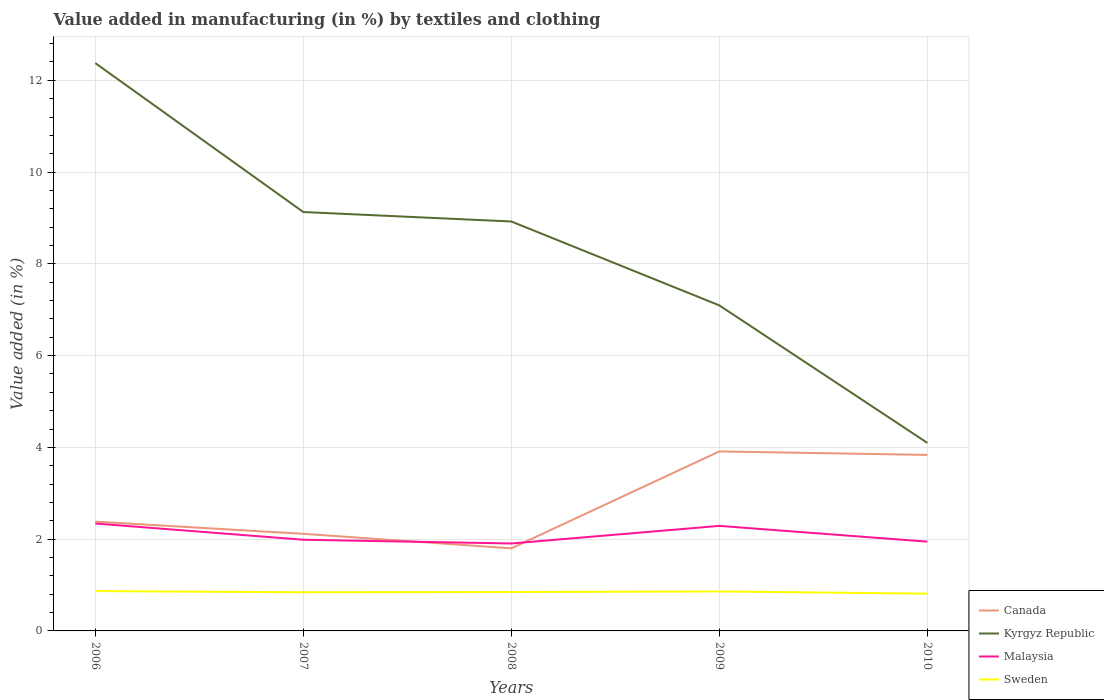How many different coloured lines are there?
Keep it short and to the point. 4. Does the line corresponding to Canada intersect with the line corresponding to Kyrgyz Republic?
Your response must be concise. No. Across all years, what is the maximum percentage of value added in manufacturing by textiles and clothing in Sweden?
Keep it short and to the point. 0.81. What is the total percentage of value added in manufacturing by textiles and clothing in Kyrgyz Republic in the graph?
Provide a succinct answer. 3.25. What is the difference between the highest and the second highest percentage of value added in manufacturing by textiles and clothing in Kyrgyz Republic?
Your response must be concise. 8.28. How many years are there in the graph?
Ensure brevity in your answer.  5. What is the difference between two consecutive major ticks on the Y-axis?
Make the answer very short. 2. Are the values on the major ticks of Y-axis written in scientific E-notation?
Your response must be concise. No. Does the graph contain grids?
Ensure brevity in your answer.  Yes. Where does the legend appear in the graph?
Make the answer very short. Bottom right. How are the legend labels stacked?
Give a very brief answer. Vertical. What is the title of the graph?
Keep it short and to the point. Value added in manufacturing (in %) by textiles and clothing. Does "Morocco" appear as one of the legend labels in the graph?
Your response must be concise. No. What is the label or title of the X-axis?
Your answer should be compact. Years. What is the label or title of the Y-axis?
Provide a succinct answer. Value added (in %). What is the Value added (in %) in Canada in 2006?
Offer a terse response. 2.38. What is the Value added (in %) in Kyrgyz Republic in 2006?
Your answer should be very brief. 12.37. What is the Value added (in %) of Malaysia in 2006?
Ensure brevity in your answer.  2.34. What is the Value added (in %) in Sweden in 2006?
Your response must be concise. 0.87. What is the Value added (in %) of Canada in 2007?
Give a very brief answer. 2.12. What is the Value added (in %) in Kyrgyz Republic in 2007?
Ensure brevity in your answer.  9.13. What is the Value added (in %) of Malaysia in 2007?
Provide a succinct answer. 1.99. What is the Value added (in %) in Sweden in 2007?
Give a very brief answer. 0.84. What is the Value added (in %) of Canada in 2008?
Keep it short and to the point. 1.8. What is the Value added (in %) of Kyrgyz Republic in 2008?
Provide a succinct answer. 8.92. What is the Value added (in %) of Malaysia in 2008?
Ensure brevity in your answer.  1.91. What is the Value added (in %) in Sweden in 2008?
Ensure brevity in your answer.  0.85. What is the Value added (in %) in Canada in 2009?
Keep it short and to the point. 3.91. What is the Value added (in %) in Kyrgyz Republic in 2009?
Your answer should be compact. 7.09. What is the Value added (in %) of Malaysia in 2009?
Provide a succinct answer. 2.29. What is the Value added (in %) of Sweden in 2009?
Your answer should be very brief. 0.86. What is the Value added (in %) in Canada in 2010?
Ensure brevity in your answer.  3.84. What is the Value added (in %) of Kyrgyz Republic in 2010?
Provide a succinct answer. 4.1. What is the Value added (in %) of Malaysia in 2010?
Keep it short and to the point. 1.95. What is the Value added (in %) of Sweden in 2010?
Your answer should be compact. 0.81. Across all years, what is the maximum Value added (in %) of Canada?
Your answer should be very brief. 3.91. Across all years, what is the maximum Value added (in %) of Kyrgyz Republic?
Give a very brief answer. 12.37. Across all years, what is the maximum Value added (in %) in Malaysia?
Provide a short and direct response. 2.34. Across all years, what is the maximum Value added (in %) of Sweden?
Ensure brevity in your answer.  0.87. Across all years, what is the minimum Value added (in %) in Canada?
Offer a very short reply. 1.8. Across all years, what is the minimum Value added (in %) in Kyrgyz Republic?
Your answer should be compact. 4.1. Across all years, what is the minimum Value added (in %) in Malaysia?
Ensure brevity in your answer.  1.91. Across all years, what is the minimum Value added (in %) of Sweden?
Ensure brevity in your answer.  0.81. What is the total Value added (in %) in Canada in the graph?
Offer a very short reply. 14.05. What is the total Value added (in %) in Kyrgyz Republic in the graph?
Offer a terse response. 41.62. What is the total Value added (in %) of Malaysia in the graph?
Make the answer very short. 10.47. What is the total Value added (in %) of Sweden in the graph?
Offer a very short reply. 4.23. What is the difference between the Value added (in %) of Canada in 2006 and that in 2007?
Make the answer very short. 0.27. What is the difference between the Value added (in %) of Kyrgyz Republic in 2006 and that in 2007?
Your answer should be compact. 3.25. What is the difference between the Value added (in %) in Malaysia in 2006 and that in 2007?
Keep it short and to the point. 0.35. What is the difference between the Value added (in %) of Sweden in 2006 and that in 2007?
Ensure brevity in your answer.  0.03. What is the difference between the Value added (in %) in Canada in 2006 and that in 2008?
Your answer should be very brief. 0.58. What is the difference between the Value added (in %) in Kyrgyz Republic in 2006 and that in 2008?
Give a very brief answer. 3.45. What is the difference between the Value added (in %) in Malaysia in 2006 and that in 2008?
Your response must be concise. 0.44. What is the difference between the Value added (in %) of Sweden in 2006 and that in 2008?
Your answer should be compact. 0.02. What is the difference between the Value added (in %) of Canada in 2006 and that in 2009?
Your answer should be compact. -1.53. What is the difference between the Value added (in %) of Kyrgyz Republic in 2006 and that in 2009?
Offer a terse response. 5.28. What is the difference between the Value added (in %) of Malaysia in 2006 and that in 2009?
Your answer should be compact. 0.05. What is the difference between the Value added (in %) in Sweden in 2006 and that in 2009?
Offer a very short reply. 0.01. What is the difference between the Value added (in %) in Canada in 2006 and that in 2010?
Provide a succinct answer. -1.45. What is the difference between the Value added (in %) of Kyrgyz Republic in 2006 and that in 2010?
Provide a succinct answer. 8.28. What is the difference between the Value added (in %) of Malaysia in 2006 and that in 2010?
Provide a short and direct response. 0.4. What is the difference between the Value added (in %) in Sweden in 2006 and that in 2010?
Offer a terse response. 0.06. What is the difference between the Value added (in %) of Canada in 2007 and that in 2008?
Provide a short and direct response. 0.32. What is the difference between the Value added (in %) in Kyrgyz Republic in 2007 and that in 2008?
Offer a very short reply. 0.21. What is the difference between the Value added (in %) of Malaysia in 2007 and that in 2008?
Offer a very short reply. 0.08. What is the difference between the Value added (in %) in Sweden in 2007 and that in 2008?
Ensure brevity in your answer.  -0.01. What is the difference between the Value added (in %) in Canada in 2007 and that in 2009?
Your answer should be very brief. -1.8. What is the difference between the Value added (in %) in Kyrgyz Republic in 2007 and that in 2009?
Keep it short and to the point. 2.03. What is the difference between the Value added (in %) in Malaysia in 2007 and that in 2009?
Offer a terse response. -0.3. What is the difference between the Value added (in %) in Sweden in 2007 and that in 2009?
Give a very brief answer. -0.02. What is the difference between the Value added (in %) of Canada in 2007 and that in 2010?
Offer a terse response. -1.72. What is the difference between the Value added (in %) in Kyrgyz Republic in 2007 and that in 2010?
Your response must be concise. 5.03. What is the difference between the Value added (in %) of Malaysia in 2007 and that in 2010?
Your response must be concise. 0.04. What is the difference between the Value added (in %) in Sweden in 2007 and that in 2010?
Your answer should be compact. 0.03. What is the difference between the Value added (in %) in Canada in 2008 and that in 2009?
Keep it short and to the point. -2.11. What is the difference between the Value added (in %) in Kyrgyz Republic in 2008 and that in 2009?
Offer a terse response. 1.83. What is the difference between the Value added (in %) of Malaysia in 2008 and that in 2009?
Provide a succinct answer. -0.38. What is the difference between the Value added (in %) in Sweden in 2008 and that in 2009?
Your answer should be very brief. -0.01. What is the difference between the Value added (in %) in Canada in 2008 and that in 2010?
Your answer should be compact. -2.04. What is the difference between the Value added (in %) of Kyrgyz Republic in 2008 and that in 2010?
Give a very brief answer. 4.82. What is the difference between the Value added (in %) of Malaysia in 2008 and that in 2010?
Ensure brevity in your answer.  -0.04. What is the difference between the Value added (in %) in Sweden in 2008 and that in 2010?
Keep it short and to the point. 0.04. What is the difference between the Value added (in %) of Canada in 2009 and that in 2010?
Keep it short and to the point. 0.08. What is the difference between the Value added (in %) in Kyrgyz Republic in 2009 and that in 2010?
Your response must be concise. 3. What is the difference between the Value added (in %) in Malaysia in 2009 and that in 2010?
Provide a short and direct response. 0.34. What is the difference between the Value added (in %) of Sweden in 2009 and that in 2010?
Offer a terse response. 0.05. What is the difference between the Value added (in %) of Canada in 2006 and the Value added (in %) of Kyrgyz Republic in 2007?
Your answer should be very brief. -6.75. What is the difference between the Value added (in %) of Canada in 2006 and the Value added (in %) of Malaysia in 2007?
Your answer should be very brief. 0.39. What is the difference between the Value added (in %) in Canada in 2006 and the Value added (in %) in Sweden in 2007?
Offer a terse response. 1.54. What is the difference between the Value added (in %) of Kyrgyz Republic in 2006 and the Value added (in %) of Malaysia in 2007?
Make the answer very short. 10.39. What is the difference between the Value added (in %) in Kyrgyz Republic in 2006 and the Value added (in %) in Sweden in 2007?
Offer a terse response. 11.53. What is the difference between the Value added (in %) in Malaysia in 2006 and the Value added (in %) in Sweden in 2007?
Your answer should be very brief. 1.5. What is the difference between the Value added (in %) of Canada in 2006 and the Value added (in %) of Kyrgyz Republic in 2008?
Your answer should be very brief. -6.54. What is the difference between the Value added (in %) in Canada in 2006 and the Value added (in %) in Malaysia in 2008?
Offer a very short reply. 0.48. What is the difference between the Value added (in %) in Canada in 2006 and the Value added (in %) in Sweden in 2008?
Provide a succinct answer. 1.53. What is the difference between the Value added (in %) in Kyrgyz Republic in 2006 and the Value added (in %) in Malaysia in 2008?
Provide a succinct answer. 10.47. What is the difference between the Value added (in %) of Kyrgyz Republic in 2006 and the Value added (in %) of Sweden in 2008?
Offer a terse response. 11.53. What is the difference between the Value added (in %) in Malaysia in 2006 and the Value added (in %) in Sweden in 2008?
Offer a terse response. 1.49. What is the difference between the Value added (in %) of Canada in 2006 and the Value added (in %) of Kyrgyz Republic in 2009?
Give a very brief answer. -4.71. What is the difference between the Value added (in %) of Canada in 2006 and the Value added (in %) of Malaysia in 2009?
Give a very brief answer. 0.09. What is the difference between the Value added (in %) of Canada in 2006 and the Value added (in %) of Sweden in 2009?
Your answer should be very brief. 1.52. What is the difference between the Value added (in %) of Kyrgyz Republic in 2006 and the Value added (in %) of Malaysia in 2009?
Offer a very short reply. 10.09. What is the difference between the Value added (in %) of Kyrgyz Republic in 2006 and the Value added (in %) of Sweden in 2009?
Ensure brevity in your answer.  11.51. What is the difference between the Value added (in %) of Malaysia in 2006 and the Value added (in %) of Sweden in 2009?
Your response must be concise. 1.48. What is the difference between the Value added (in %) of Canada in 2006 and the Value added (in %) of Kyrgyz Republic in 2010?
Your response must be concise. -1.72. What is the difference between the Value added (in %) of Canada in 2006 and the Value added (in %) of Malaysia in 2010?
Keep it short and to the point. 0.44. What is the difference between the Value added (in %) of Canada in 2006 and the Value added (in %) of Sweden in 2010?
Keep it short and to the point. 1.57. What is the difference between the Value added (in %) of Kyrgyz Republic in 2006 and the Value added (in %) of Malaysia in 2010?
Your answer should be very brief. 10.43. What is the difference between the Value added (in %) of Kyrgyz Republic in 2006 and the Value added (in %) of Sweden in 2010?
Provide a succinct answer. 11.56. What is the difference between the Value added (in %) in Malaysia in 2006 and the Value added (in %) in Sweden in 2010?
Provide a short and direct response. 1.53. What is the difference between the Value added (in %) of Canada in 2007 and the Value added (in %) of Kyrgyz Republic in 2008?
Your answer should be very brief. -6.81. What is the difference between the Value added (in %) in Canada in 2007 and the Value added (in %) in Malaysia in 2008?
Provide a succinct answer. 0.21. What is the difference between the Value added (in %) in Canada in 2007 and the Value added (in %) in Sweden in 2008?
Your answer should be very brief. 1.27. What is the difference between the Value added (in %) in Kyrgyz Republic in 2007 and the Value added (in %) in Malaysia in 2008?
Your answer should be compact. 7.22. What is the difference between the Value added (in %) of Kyrgyz Republic in 2007 and the Value added (in %) of Sweden in 2008?
Provide a succinct answer. 8.28. What is the difference between the Value added (in %) in Malaysia in 2007 and the Value added (in %) in Sweden in 2008?
Keep it short and to the point. 1.14. What is the difference between the Value added (in %) of Canada in 2007 and the Value added (in %) of Kyrgyz Republic in 2009?
Provide a succinct answer. -4.98. What is the difference between the Value added (in %) in Canada in 2007 and the Value added (in %) in Malaysia in 2009?
Offer a very short reply. -0.17. What is the difference between the Value added (in %) of Canada in 2007 and the Value added (in %) of Sweden in 2009?
Keep it short and to the point. 1.26. What is the difference between the Value added (in %) of Kyrgyz Republic in 2007 and the Value added (in %) of Malaysia in 2009?
Offer a very short reply. 6.84. What is the difference between the Value added (in %) of Kyrgyz Republic in 2007 and the Value added (in %) of Sweden in 2009?
Your answer should be very brief. 8.27. What is the difference between the Value added (in %) in Malaysia in 2007 and the Value added (in %) in Sweden in 2009?
Offer a very short reply. 1.13. What is the difference between the Value added (in %) in Canada in 2007 and the Value added (in %) in Kyrgyz Republic in 2010?
Your answer should be compact. -1.98. What is the difference between the Value added (in %) of Canada in 2007 and the Value added (in %) of Malaysia in 2010?
Provide a succinct answer. 0.17. What is the difference between the Value added (in %) of Canada in 2007 and the Value added (in %) of Sweden in 2010?
Your answer should be very brief. 1.3. What is the difference between the Value added (in %) in Kyrgyz Republic in 2007 and the Value added (in %) in Malaysia in 2010?
Give a very brief answer. 7.18. What is the difference between the Value added (in %) of Kyrgyz Republic in 2007 and the Value added (in %) of Sweden in 2010?
Provide a short and direct response. 8.32. What is the difference between the Value added (in %) in Malaysia in 2007 and the Value added (in %) in Sweden in 2010?
Keep it short and to the point. 1.18. What is the difference between the Value added (in %) in Canada in 2008 and the Value added (in %) in Kyrgyz Republic in 2009?
Offer a terse response. -5.29. What is the difference between the Value added (in %) of Canada in 2008 and the Value added (in %) of Malaysia in 2009?
Your answer should be very brief. -0.49. What is the difference between the Value added (in %) of Canada in 2008 and the Value added (in %) of Sweden in 2009?
Your response must be concise. 0.94. What is the difference between the Value added (in %) in Kyrgyz Republic in 2008 and the Value added (in %) in Malaysia in 2009?
Keep it short and to the point. 6.63. What is the difference between the Value added (in %) in Kyrgyz Republic in 2008 and the Value added (in %) in Sweden in 2009?
Provide a short and direct response. 8.06. What is the difference between the Value added (in %) in Malaysia in 2008 and the Value added (in %) in Sweden in 2009?
Offer a very short reply. 1.04. What is the difference between the Value added (in %) in Canada in 2008 and the Value added (in %) in Kyrgyz Republic in 2010?
Provide a succinct answer. -2.3. What is the difference between the Value added (in %) of Canada in 2008 and the Value added (in %) of Malaysia in 2010?
Your response must be concise. -0.15. What is the difference between the Value added (in %) of Canada in 2008 and the Value added (in %) of Sweden in 2010?
Keep it short and to the point. 0.99. What is the difference between the Value added (in %) of Kyrgyz Republic in 2008 and the Value added (in %) of Malaysia in 2010?
Offer a very short reply. 6.98. What is the difference between the Value added (in %) in Kyrgyz Republic in 2008 and the Value added (in %) in Sweden in 2010?
Make the answer very short. 8.11. What is the difference between the Value added (in %) in Malaysia in 2008 and the Value added (in %) in Sweden in 2010?
Provide a succinct answer. 1.09. What is the difference between the Value added (in %) of Canada in 2009 and the Value added (in %) of Kyrgyz Republic in 2010?
Give a very brief answer. -0.19. What is the difference between the Value added (in %) in Canada in 2009 and the Value added (in %) in Malaysia in 2010?
Your response must be concise. 1.97. What is the difference between the Value added (in %) in Canada in 2009 and the Value added (in %) in Sweden in 2010?
Offer a very short reply. 3.1. What is the difference between the Value added (in %) in Kyrgyz Republic in 2009 and the Value added (in %) in Malaysia in 2010?
Your answer should be very brief. 5.15. What is the difference between the Value added (in %) of Kyrgyz Republic in 2009 and the Value added (in %) of Sweden in 2010?
Give a very brief answer. 6.28. What is the difference between the Value added (in %) in Malaysia in 2009 and the Value added (in %) in Sweden in 2010?
Ensure brevity in your answer.  1.48. What is the average Value added (in %) in Canada per year?
Offer a very short reply. 2.81. What is the average Value added (in %) in Kyrgyz Republic per year?
Ensure brevity in your answer.  8.32. What is the average Value added (in %) in Malaysia per year?
Ensure brevity in your answer.  2.09. What is the average Value added (in %) in Sweden per year?
Ensure brevity in your answer.  0.85. In the year 2006, what is the difference between the Value added (in %) in Canada and Value added (in %) in Kyrgyz Republic?
Your answer should be very brief. -9.99. In the year 2006, what is the difference between the Value added (in %) in Canada and Value added (in %) in Malaysia?
Offer a very short reply. 0.04. In the year 2006, what is the difference between the Value added (in %) in Canada and Value added (in %) in Sweden?
Your response must be concise. 1.51. In the year 2006, what is the difference between the Value added (in %) of Kyrgyz Republic and Value added (in %) of Malaysia?
Provide a succinct answer. 10.03. In the year 2006, what is the difference between the Value added (in %) in Kyrgyz Republic and Value added (in %) in Sweden?
Offer a very short reply. 11.51. In the year 2006, what is the difference between the Value added (in %) in Malaysia and Value added (in %) in Sweden?
Your answer should be very brief. 1.47. In the year 2007, what is the difference between the Value added (in %) of Canada and Value added (in %) of Kyrgyz Republic?
Make the answer very short. -7.01. In the year 2007, what is the difference between the Value added (in %) in Canada and Value added (in %) in Malaysia?
Keep it short and to the point. 0.13. In the year 2007, what is the difference between the Value added (in %) of Canada and Value added (in %) of Sweden?
Provide a succinct answer. 1.27. In the year 2007, what is the difference between the Value added (in %) of Kyrgyz Republic and Value added (in %) of Malaysia?
Offer a very short reply. 7.14. In the year 2007, what is the difference between the Value added (in %) in Kyrgyz Republic and Value added (in %) in Sweden?
Keep it short and to the point. 8.29. In the year 2007, what is the difference between the Value added (in %) in Malaysia and Value added (in %) in Sweden?
Your response must be concise. 1.14. In the year 2008, what is the difference between the Value added (in %) of Canada and Value added (in %) of Kyrgyz Republic?
Your answer should be compact. -7.12. In the year 2008, what is the difference between the Value added (in %) of Canada and Value added (in %) of Malaysia?
Provide a short and direct response. -0.11. In the year 2008, what is the difference between the Value added (in %) of Canada and Value added (in %) of Sweden?
Provide a short and direct response. 0.95. In the year 2008, what is the difference between the Value added (in %) of Kyrgyz Republic and Value added (in %) of Malaysia?
Provide a succinct answer. 7.02. In the year 2008, what is the difference between the Value added (in %) of Kyrgyz Republic and Value added (in %) of Sweden?
Provide a succinct answer. 8.08. In the year 2008, what is the difference between the Value added (in %) of Malaysia and Value added (in %) of Sweden?
Your answer should be compact. 1.06. In the year 2009, what is the difference between the Value added (in %) of Canada and Value added (in %) of Kyrgyz Republic?
Give a very brief answer. -3.18. In the year 2009, what is the difference between the Value added (in %) of Canada and Value added (in %) of Malaysia?
Keep it short and to the point. 1.62. In the year 2009, what is the difference between the Value added (in %) in Canada and Value added (in %) in Sweden?
Provide a succinct answer. 3.05. In the year 2009, what is the difference between the Value added (in %) in Kyrgyz Republic and Value added (in %) in Malaysia?
Offer a terse response. 4.81. In the year 2009, what is the difference between the Value added (in %) of Kyrgyz Republic and Value added (in %) of Sweden?
Your response must be concise. 6.23. In the year 2009, what is the difference between the Value added (in %) in Malaysia and Value added (in %) in Sweden?
Your response must be concise. 1.43. In the year 2010, what is the difference between the Value added (in %) in Canada and Value added (in %) in Kyrgyz Republic?
Your response must be concise. -0.26. In the year 2010, what is the difference between the Value added (in %) of Canada and Value added (in %) of Malaysia?
Ensure brevity in your answer.  1.89. In the year 2010, what is the difference between the Value added (in %) in Canada and Value added (in %) in Sweden?
Provide a short and direct response. 3.02. In the year 2010, what is the difference between the Value added (in %) of Kyrgyz Republic and Value added (in %) of Malaysia?
Provide a succinct answer. 2.15. In the year 2010, what is the difference between the Value added (in %) in Kyrgyz Republic and Value added (in %) in Sweden?
Provide a short and direct response. 3.29. In the year 2010, what is the difference between the Value added (in %) of Malaysia and Value added (in %) of Sweden?
Your answer should be compact. 1.13. What is the ratio of the Value added (in %) of Canada in 2006 to that in 2007?
Make the answer very short. 1.13. What is the ratio of the Value added (in %) of Kyrgyz Republic in 2006 to that in 2007?
Offer a terse response. 1.36. What is the ratio of the Value added (in %) in Malaysia in 2006 to that in 2007?
Make the answer very short. 1.18. What is the ratio of the Value added (in %) in Sweden in 2006 to that in 2007?
Give a very brief answer. 1.03. What is the ratio of the Value added (in %) in Canada in 2006 to that in 2008?
Your response must be concise. 1.32. What is the ratio of the Value added (in %) of Kyrgyz Republic in 2006 to that in 2008?
Give a very brief answer. 1.39. What is the ratio of the Value added (in %) in Malaysia in 2006 to that in 2008?
Your answer should be compact. 1.23. What is the ratio of the Value added (in %) of Sweden in 2006 to that in 2008?
Ensure brevity in your answer.  1.02. What is the ratio of the Value added (in %) in Canada in 2006 to that in 2009?
Provide a short and direct response. 0.61. What is the ratio of the Value added (in %) in Kyrgyz Republic in 2006 to that in 2009?
Ensure brevity in your answer.  1.74. What is the ratio of the Value added (in %) of Malaysia in 2006 to that in 2009?
Provide a succinct answer. 1.02. What is the ratio of the Value added (in %) of Sweden in 2006 to that in 2009?
Make the answer very short. 1.01. What is the ratio of the Value added (in %) in Canada in 2006 to that in 2010?
Keep it short and to the point. 0.62. What is the ratio of the Value added (in %) in Kyrgyz Republic in 2006 to that in 2010?
Provide a succinct answer. 3.02. What is the ratio of the Value added (in %) in Malaysia in 2006 to that in 2010?
Give a very brief answer. 1.2. What is the ratio of the Value added (in %) of Sweden in 2006 to that in 2010?
Ensure brevity in your answer.  1.07. What is the ratio of the Value added (in %) of Canada in 2007 to that in 2008?
Give a very brief answer. 1.18. What is the ratio of the Value added (in %) of Kyrgyz Republic in 2007 to that in 2008?
Provide a short and direct response. 1.02. What is the ratio of the Value added (in %) in Malaysia in 2007 to that in 2008?
Your answer should be compact. 1.04. What is the ratio of the Value added (in %) in Sweden in 2007 to that in 2008?
Your response must be concise. 0.99. What is the ratio of the Value added (in %) in Canada in 2007 to that in 2009?
Your answer should be compact. 0.54. What is the ratio of the Value added (in %) of Kyrgyz Republic in 2007 to that in 2009?
Offer a terse response. 1.29. What is the ratio of the Value added (in %) in Malaysia in 2007 to that in 2009?
Offer a terse response. 0.87. What is the ratio of the Value added (in %) in Sweden in 2007 to that in 2009?
Give a very brief answer. 0.98. What is the ratio of the Value added (in %) in Canada in 2007 to that in 2010?
Your answer should be very brief. 0.55. What is the ratio of the Value added (in %) in Kyrgyz Republic in 2007 to that in 2010?
Keep it short and to the point. 2.23. What is the ratio of the Value added (in %) of Malaysia in 2007 to that in 2010?
Your answer should be compact. 1.02. What is the ratio of the Value added (in %) of Sweden in 2007 to that in 2010?
Offer a terse response. 1.04. What is the ratio of the Value added (in %) in Canada in 2008 to that in 2009?
Keep it short and to the point. 0.46. What is the ratio of the Value added (in %) of Kyrgyz Republic in 2008 to that in 2009?
Give a very brief answer. 1.26. What is the ratio of the Value added (in %) of Malaysia in 2008 to that in 2009?
Your answer should be compact. 0.83. What is the ratio of the Value added (in %) of Sweden in 2008 to that in 2009?
Your answer should be very brief. 0.98. What is the ratio of the Value added (in %) in Canada in 2008 to that in 2010?
Give a very brief answer. 0.47. What is the ratio of the Value added (in %) of Kyrgyz Republic in 2008 to that in 2010?
Ensure brevity in your answer.  2.18. What is the ratio of the Value added (in %) in Malaysia in 2008 to that in 2010?
Make the answer very short. 0.98. What is the ratio of the Value added (in %) in Sweden in 2008 to that in 2010?
Give a very brief answer. 1.04. What is the ratio of the Value added (in %) in Canada in 2009 to that in 2010?
Offer a very short reply. 1.02. What is the ratio of the Value added (in %) of Kyrgyz Republic in 2009 to that in 2010?
Your answer should be compact. 1.73. What is the ratio of the Value added (in %) in Malaysia in 2009 to that in 2010?
Offer a very short reply. 1.18. What is the ratio of the Value added (in %) in Sweden in 2009 to that in 2010?
Ensure brevity in your answer.  1.06. What is the difference between the highest and the second highest Value added (in %) of Canada?
Keep it short and to the point. 0.08. What is the difference between the highest and the second highest Value added (in %) in Kyrgyz Republic?
Make the answer very short. 3.25. What is the difference between the highest and the second highest Value added (in %) of Malaysia?
Your answer should be compact. 0.05. What is the difference between the highest and the second highest Value added (in %) in Sweden?
Make the answer very short. 0.01. What is the difference between the highest and the lowest Value added (in %) in Canada?
Keep it short and to the point. 2.11. What is the difference between the highest and the lowest Value added (in %) in Kyrgyz Republic?
Make the answer very short. 8.28. What is the difference between the highest and the lowest Value added (in %) of Malaysia?
Offer a very short reply. 0.44. What is the difference between the highest and the lowest Value added (in %) of Sweden?
Offer a very short reply. 0.06. 